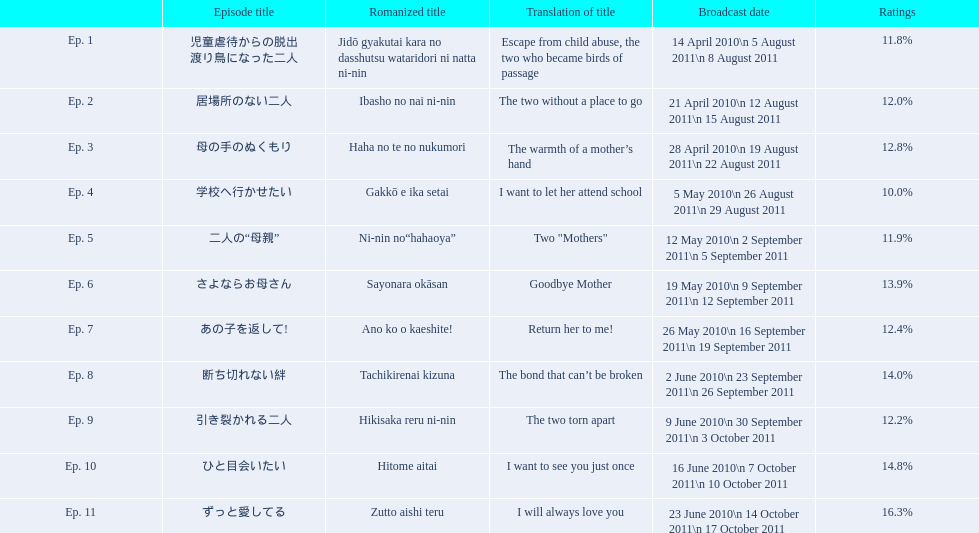What were all the episode titles for the show mother? 児童虐待からの脱出 渡り鳥になった二人, 居場所のない二人, 母の手のぬくもり, 学校へ行かせたい, 二人の“母親”, さよならお母さん, あの子を返して!, 断ち切れない絆, 引き裂かれる二人, ひと目会いたい, ずっと愛してる. What were all the translated episode titles for the show mother? Escape from child abuse, the two who became birds of passage, The two without a place to go, The warmth of a mother’s hand, I want to let her attend school, Two "Mothers", Goodbye Mother, Return her to me!, The bond that can’t be broken, The two torn apart, I want to see you just once, I will always love you. Which episode was translated to i want to let her attend school? Ep. 4. 